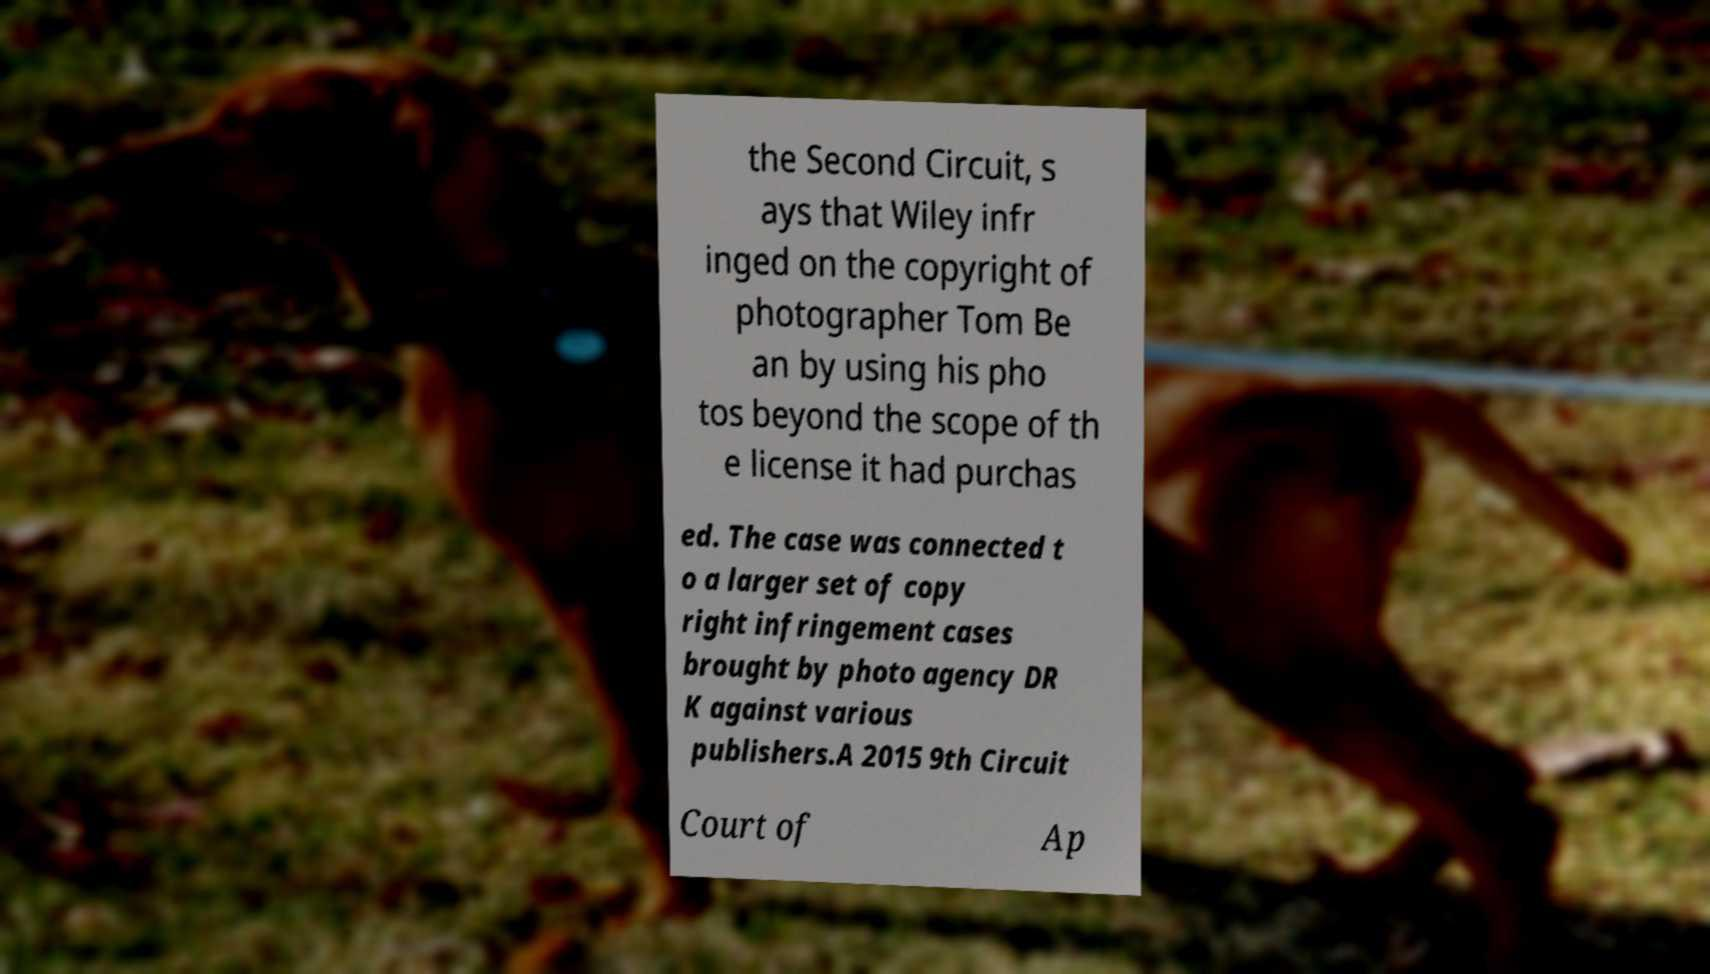Please read and relay the text visible in this image. What does it say? the Second Circuit, s ays that Wiley infr inged on the copyright of photographer Tom Be an by using his pho tos beyond the scope of th e license it had purchas ed. The case was connected t o a larger set of copy right infringement cases brought by photo agency DR K against various publishers.A 2015 9th Circuit Court of Ap 